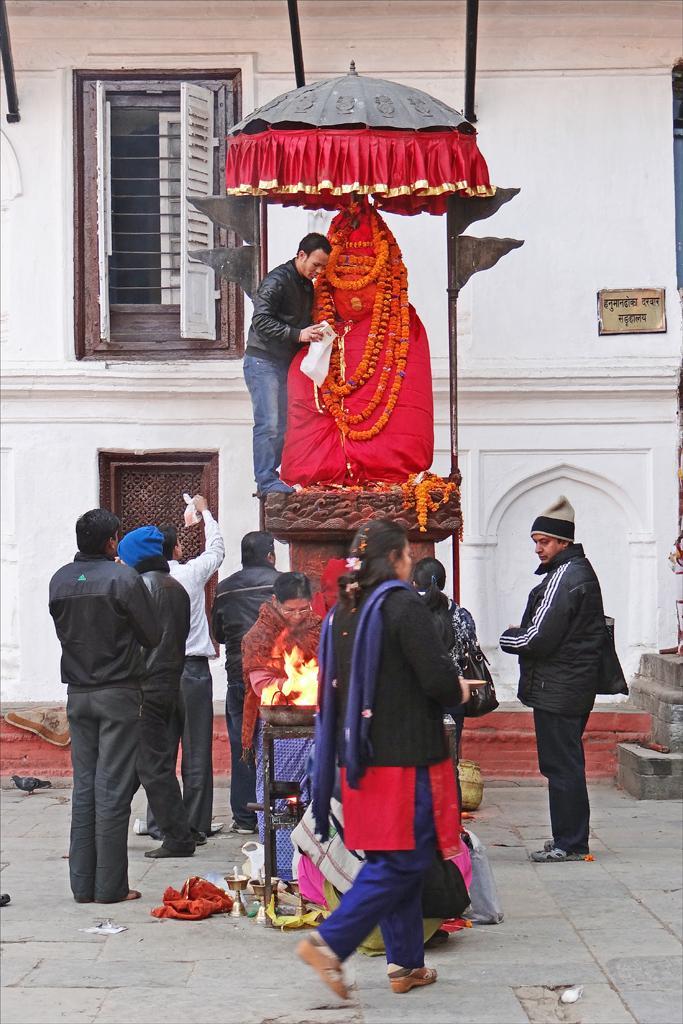Can you describe this image briefly? In this image, we can see people wearing clothes. There is a statue and umbrella in the middle of the image. There is a window in the top left of the image. In the background, we can see a wall. 